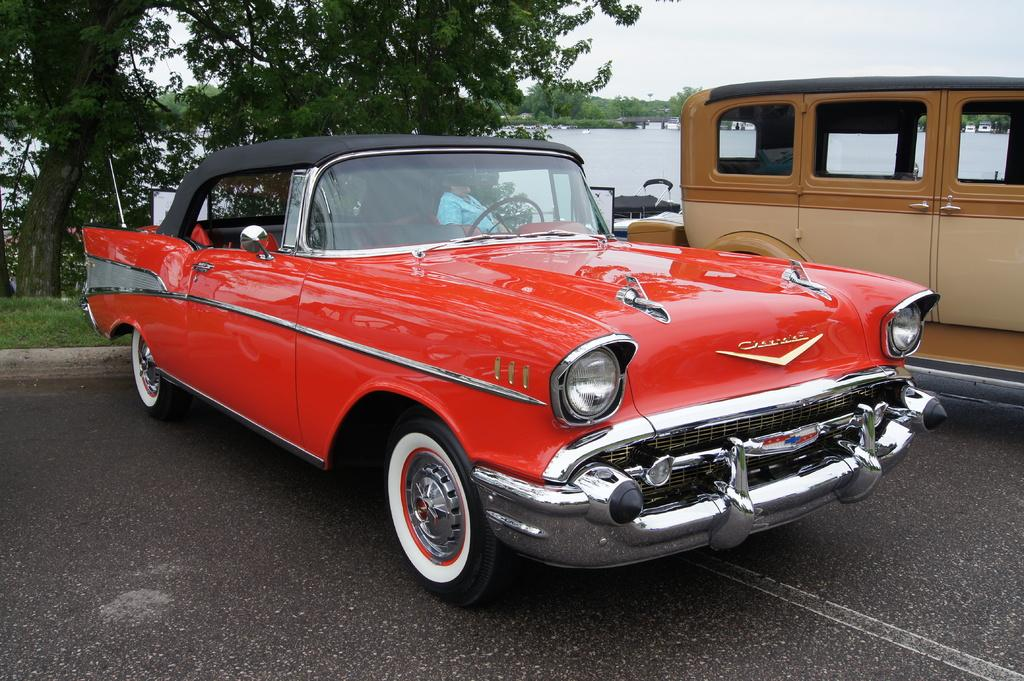What can be seen on the road in the image? There are vehicles on the road in the image. What type of vegetation is visible in the image? There is green grass visible in the image. What other natural elements can be seen in the image? There are trees in the image. What else is visible in the image besides the road and vegetation? There is water visible in the image. What type of trousers is the water wearing in the image? There are no trousers present in the image, as water is a liquid and does not wear clothing. Can you see a locket hanging from the trees in the image? There is no locket present in the image; the trees are natural elements and do not have accessories. 